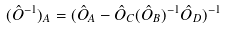Convert formula to latex. <formula><loc_0><loc_0><loc_500><loc_500>( \hat { O } ^ { - 1 } ) _ { A } = ( \hat { O } _ { A } - \hat { O } _ { C } ( \hat { O } _ { B } ) ^ { - 1 } \hat { O } _ { D } ) ^ { - 1 }</formula> 